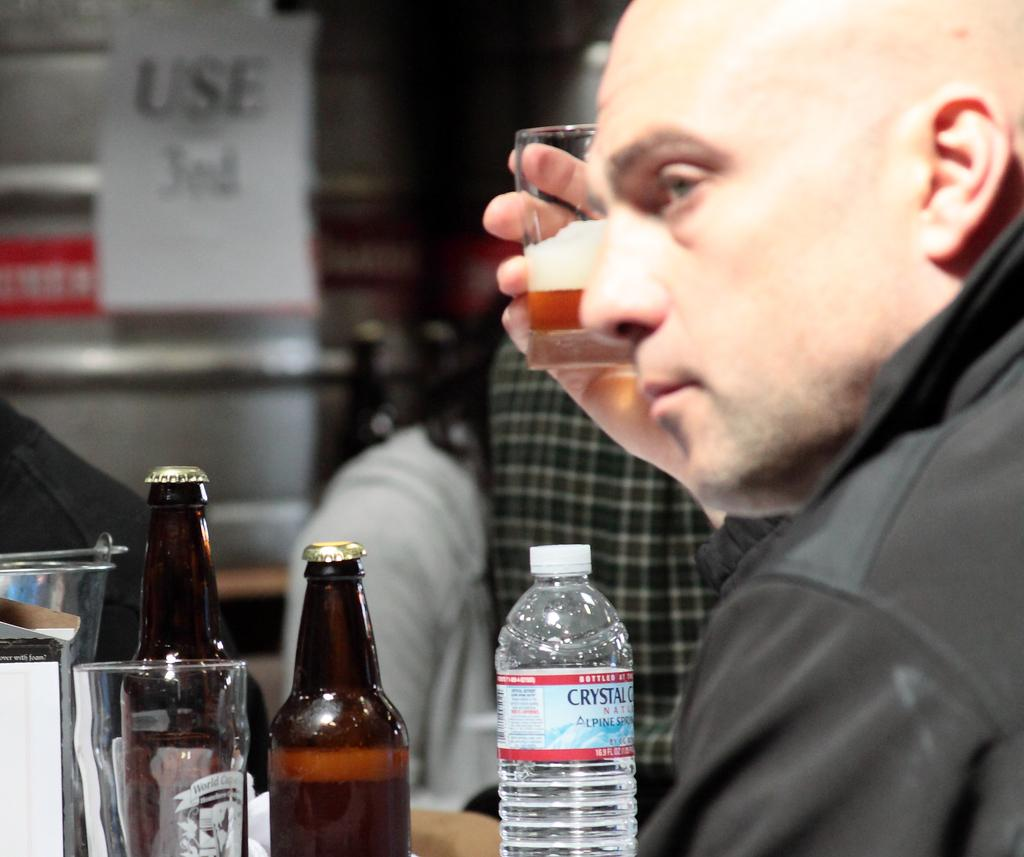<image>
Offer a succinct explanation of the picture presented. A man drinking beer also has a bottle of Crystal Geyser water in front of him. 